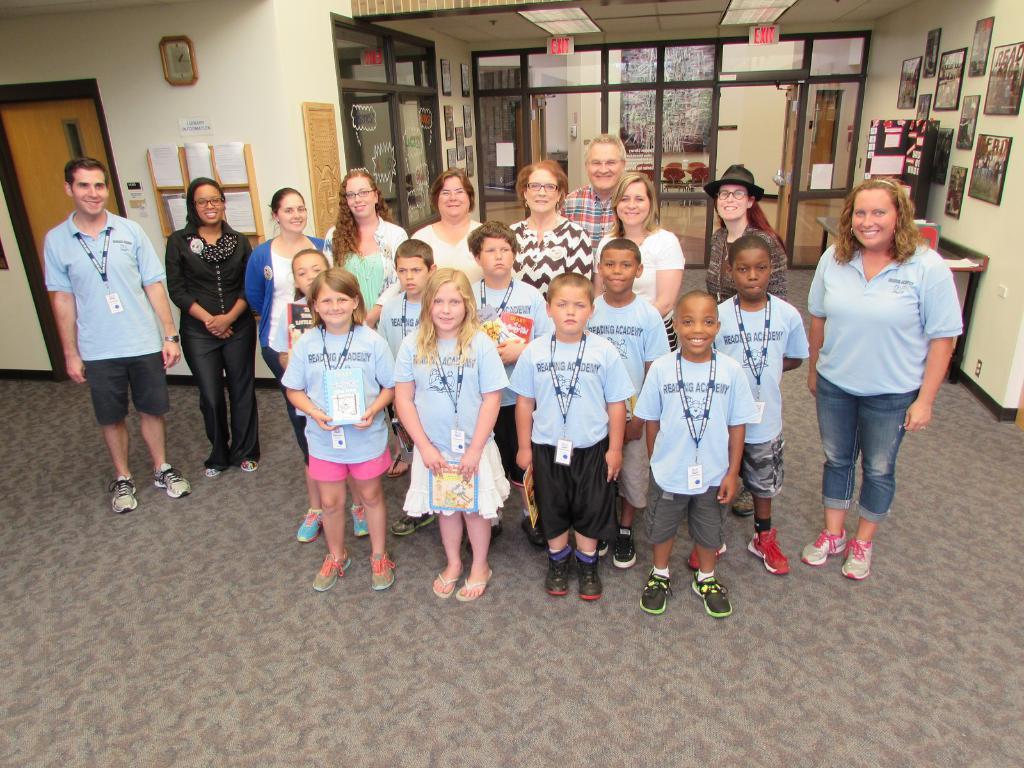In one or two sentences, can you explain what this image depicts? In this image I can see group of people standing. In front the person is wearing blue shirt, black short, background I can see few frames attached to the wall and I can also see few glass doors and the wall is in cream color. 